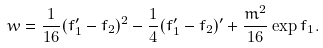<formula> <loc_0><loc_0><loc_500><loc_500>w = \frac { 1 } { 1 6 } ( f _ { 1 } ^ { \prime } - f _ { 2 } ) ^ { 2 } - \frac { 1 } { 4 } ( f _ { 1 } ^ { \prime } - f _ { 2 } ) ^ { \prime } + \frac { m ^ { 2 } } { 1 6 } \exp f _ { 1 } .</formula> 